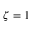<formula> <loc_0><loc_0><loc_500><loc_500>\zeta = 1</formula> 